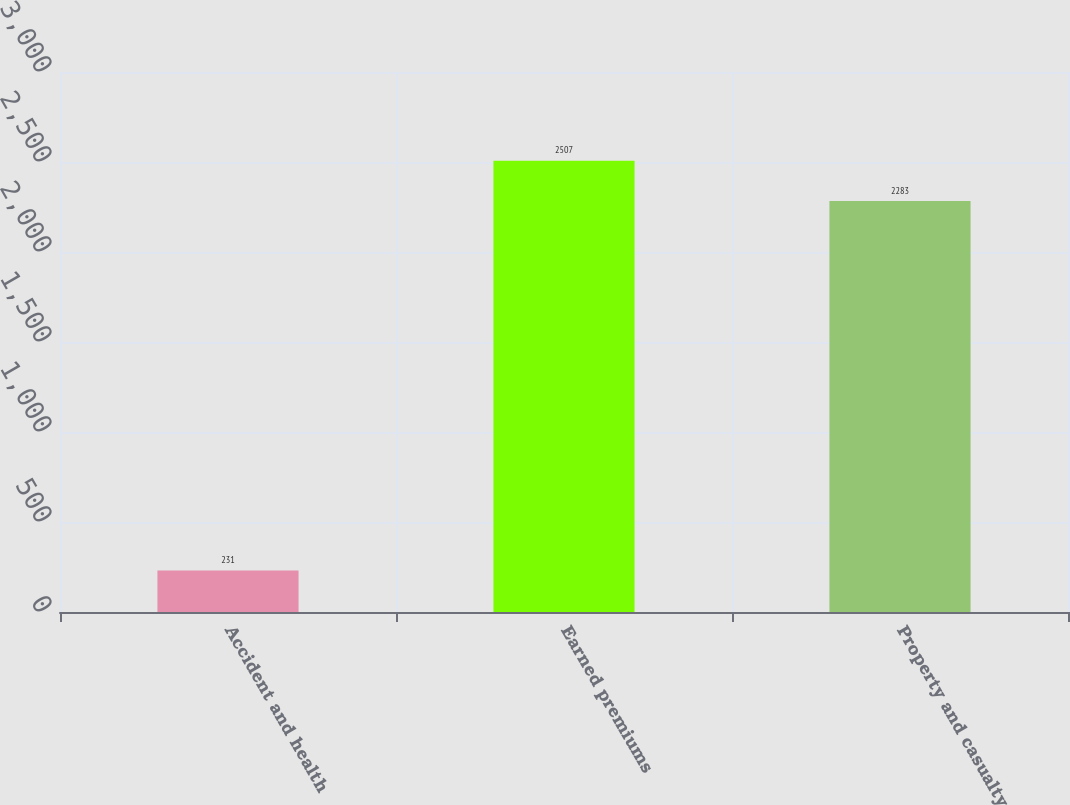Convert chart. <chart><loc_0><loc_0><loc_500><loc_500><bar_chart><fcel>Accident and health<fcel>Earned premiums<fcel>Property and casualty<nl><fcel>231<fcel>2507<fcel>2283<nl></chart> 